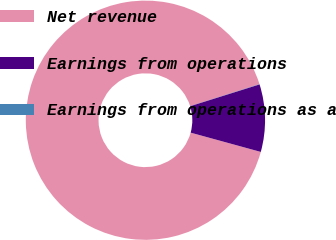<chart> <loc_0><loc_0><loc_500><loc_500><pie_chart><fcel>Net revenue<fcel>Earnings from operations<fcel>Earnings from operations as a<nl><fcel>90.86%<fcel>9.11%<fcel>0.03%<nl></chart> 